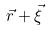<formula> <loc_0><loc_0><loc_500><loc_500>\vec { r } + \vec { \xi }</formula> 